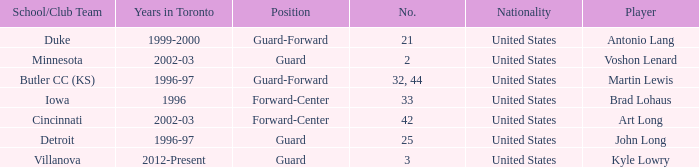What position does the player who played for butler cc (ks) play? Guard-Forward. 